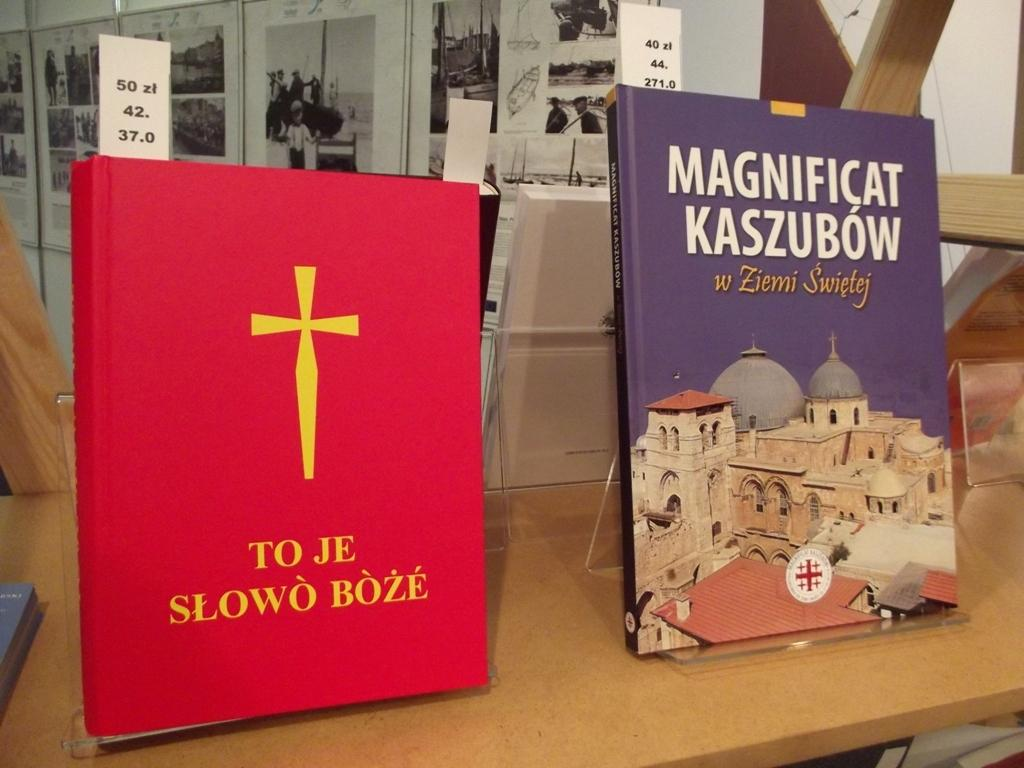<image>
Present a compact description of the photo's key features. A red book with a cross and a purple book titled Magnificat Kaszbow are displayed on the shelf. 